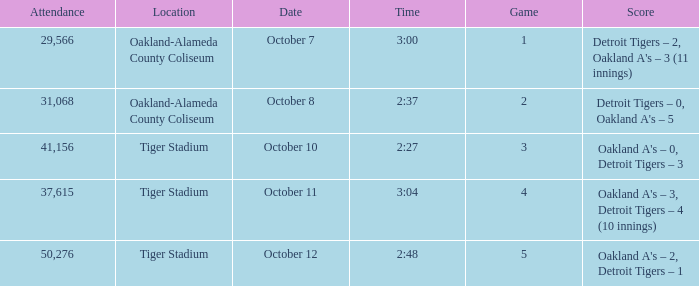What is the number of people in attendance when the time is 3:00? 29566.0. 